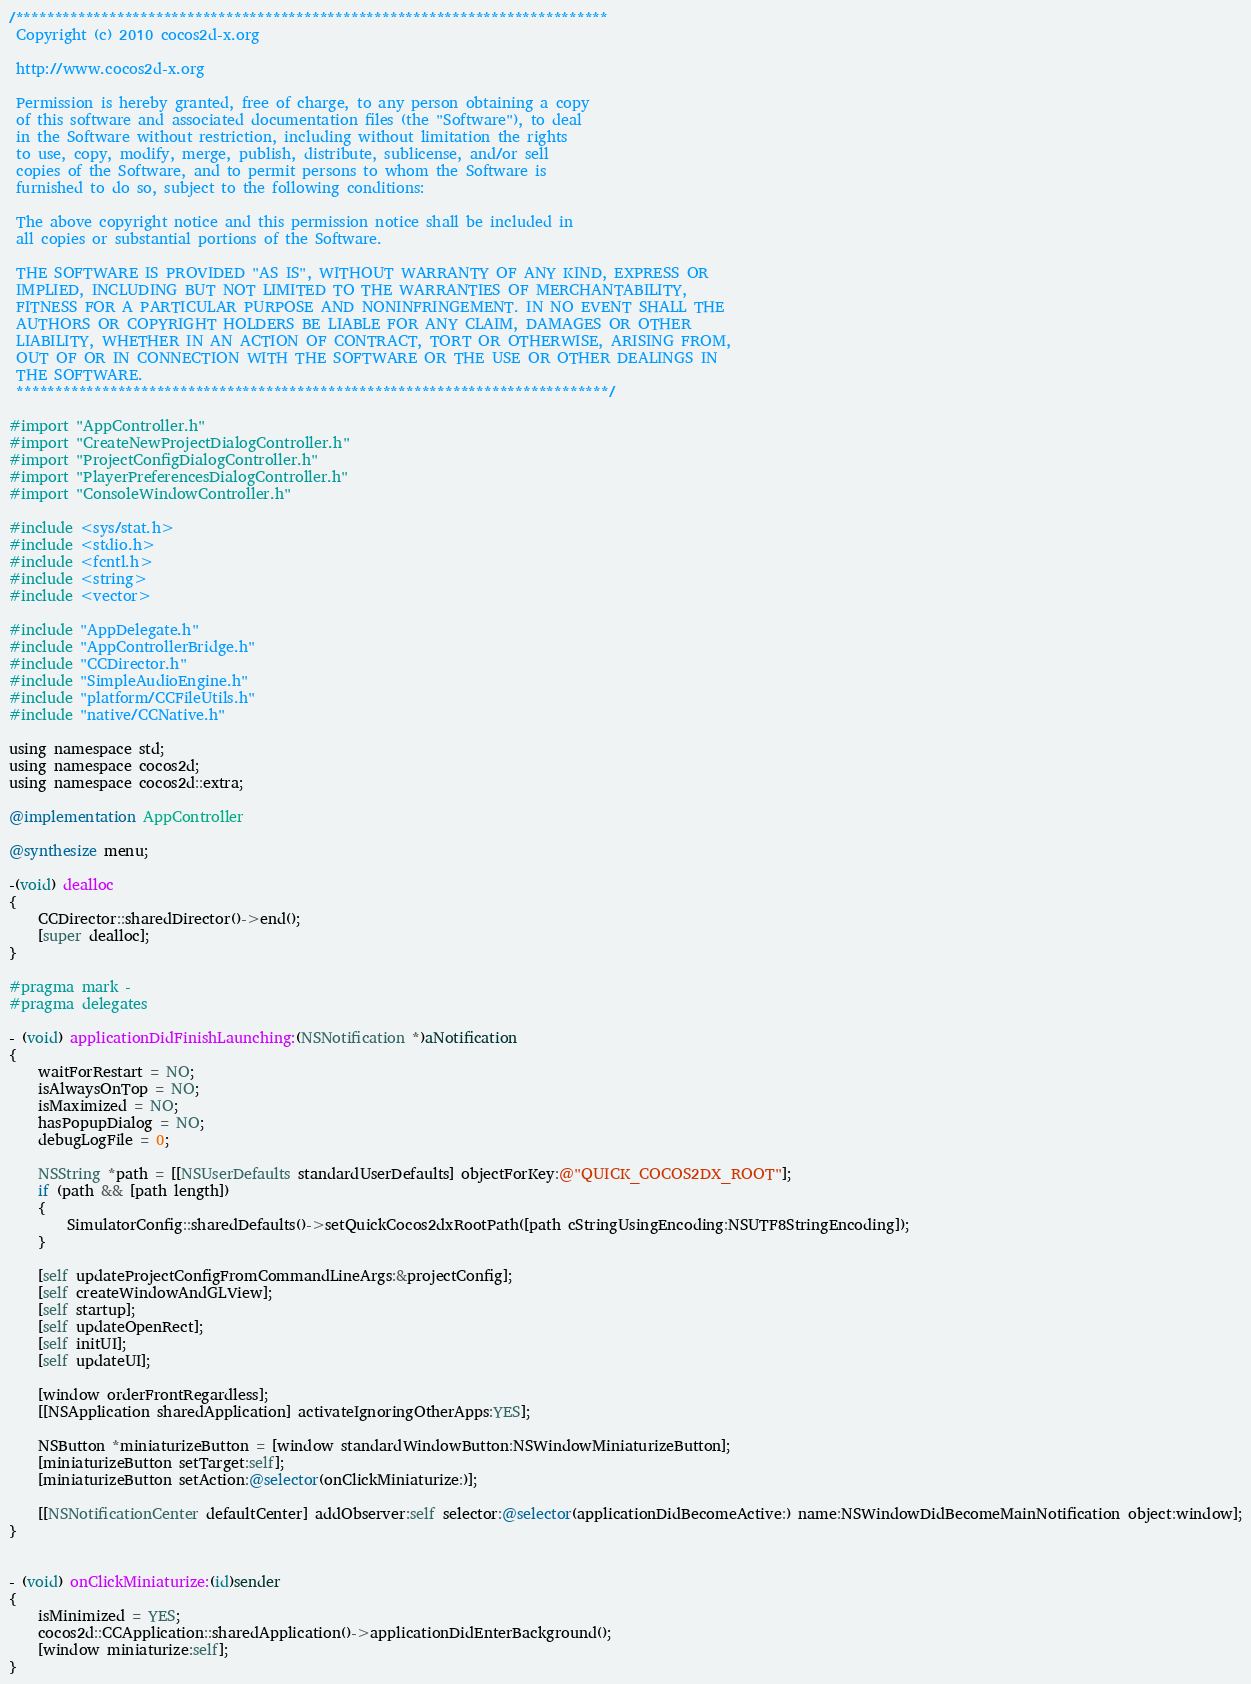<code> <loc_0><loc_0><loc_500><loc_500><_ObjectiveC_>/****************************************************************************
 Copyright (c) 2010 cocos2d-x.org

 http://www.cocos2d-x.org

 Permission is hereby granted, free of charge, to any person obtaining a copy
 of this software and associated documentation files (the "Software"), to deal
 in the Software without restriction, including without limitation the rights
 to use, copy, modify, merge, publish, distribute, sublicense, and/or sell
 copies of the Software, and to permit persons to whom the Software is
 furnished to do so, subject to the following conditions:

 The above copyright notice and this permission notice shall be included in
 all copies or substantial portions of the Software.

 THE SOFTWARE IS PROVIDED "AS IS", WITHOUT WARRANTY OF ANY KIND, EXPRESS OR
 IMPLIED, INCLUDING BUT NOT LIMITED TO THE WARRANTIES OF MERCHANTABILITY,
 FITNESS FOR A PARTICULAR PURPOSE AND NONINFRINGEMENT. IN NO EVENT SHALL THE
 AUTHORS OR COPYRIGHT HOLDERS BE LIABLE FOR ANY CLAIM, DAMAGES OR OTHER
 LIABILITY, WHETHER IN AN ACTION OF CONTRACT, TORT OR OTHERWISE, ARISING FROM,
 OUT OF OR IN CONNECTION WITH THE SOFTWARE OR THE USE OR OTHER DEALINGS IN
 THE SOFTWARE.
 ****************************************************************************/

#import "AppController.h"
#import "CreateNewProjectDialogController.h"
#import "ProjectConfigDialogController.h"
#import "PlayerPreferencesDialogController.h"
#import "ConsoleWindowController.h"

#include <sys/stat.h>
#include <stdio.h>
#include <fcntl.h>
#include <string>
#include <vector>

#include "AppDelegate.h"
#include "AppControllerBridge.h"
#include "CCDirector.h"
#include "SimpleAudioEngine.h"
#include "platform/CCFileUtils.h"
#include "native/CCNative.h"

using namespace std;
using namespace cocos2d;
using namespace cocos2d::extra;

@implementation AppController

@synthesize menu;

-(void) dealloc
{
    CCDirector::sharedDirector()->end();
    [super dealloc];
}

#pragma mark -
#pragma delegates

- (void) applicationDidFinishLaunching:(NSNotification *)aNotification
{
    waitForRestart = NO;
    isAlwaysOnTop = NO;
    isMaximized = NO;
    hasPopupDialog = NO;
    debugLogFile = 0;

    NSString *path = [[NSUserDefaults standardUserDefaults] objectForKey:@"QUICK_COCOS2DX_ROOT"];
    if (path && [path length])
    {
        SimulatorConfig::sharedDefaults()->setQuickCocos2dxRootPath([path cStringUsingEncoding:NSUTF8StringEncoding]);
    }

    [self updateProjectConfigFromCommandLineArgs:&projectConfig];
    [self createWindowAndGLView];
    [self startup];
    [self updateOpenRect];
    [self initUI];
    [self updateUI];

    [window orderFrontRegardless];
    [[NSApplication sharedApplication] activateIgnoringOtherApps:YES];
    
    NSButton *miniaturizeButton = [window standardWindowButton:NSWindowMiniaturizeButton];
    [miniaturizeButton setTarget:self];
    [miniaturizeButton setAction:@selector(onClickMiniaturize:)];

    [[NSNotificationCenter defaultCenter] addObserver:self selector:@selector(applicationDidBecomeActive:) name:NSWindowDidBecomeMainNotification object:window];
}


- (void) onClickMiniaturize:(id)sender
{
    isMinimized = YES;
    cocos2d::CCApplication::sharedApplication()->applicationDidEnterBackground();
    [window miniaturize:self];
}
</code> 